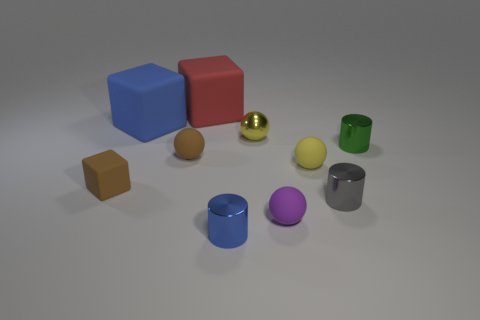Subtract all green shiny cylinders. How many cylinders are left? 2 Subtract all yellow balls. How many balls are left? 2 Subtract all blocks. How many objects are left? 7 Subtract 1 cylinders. How many cylinders are left? 2 Subtract all cyan cylinders. Subtract all gray balls. How many cylinders are left? 3 Subtract all purple cylinders. How many red blocks are left? 1 Subtract all big blue objects. Subtract all small blue objects. How many objects are left? 8 Add 5 small purple rubber things. How many small purple rubber things are left? 6 Add 8 tiny green shiny objects. How many tiny green shiny objects exist? 9 Subtract 1 yellow balls. How many objects are left? 9 